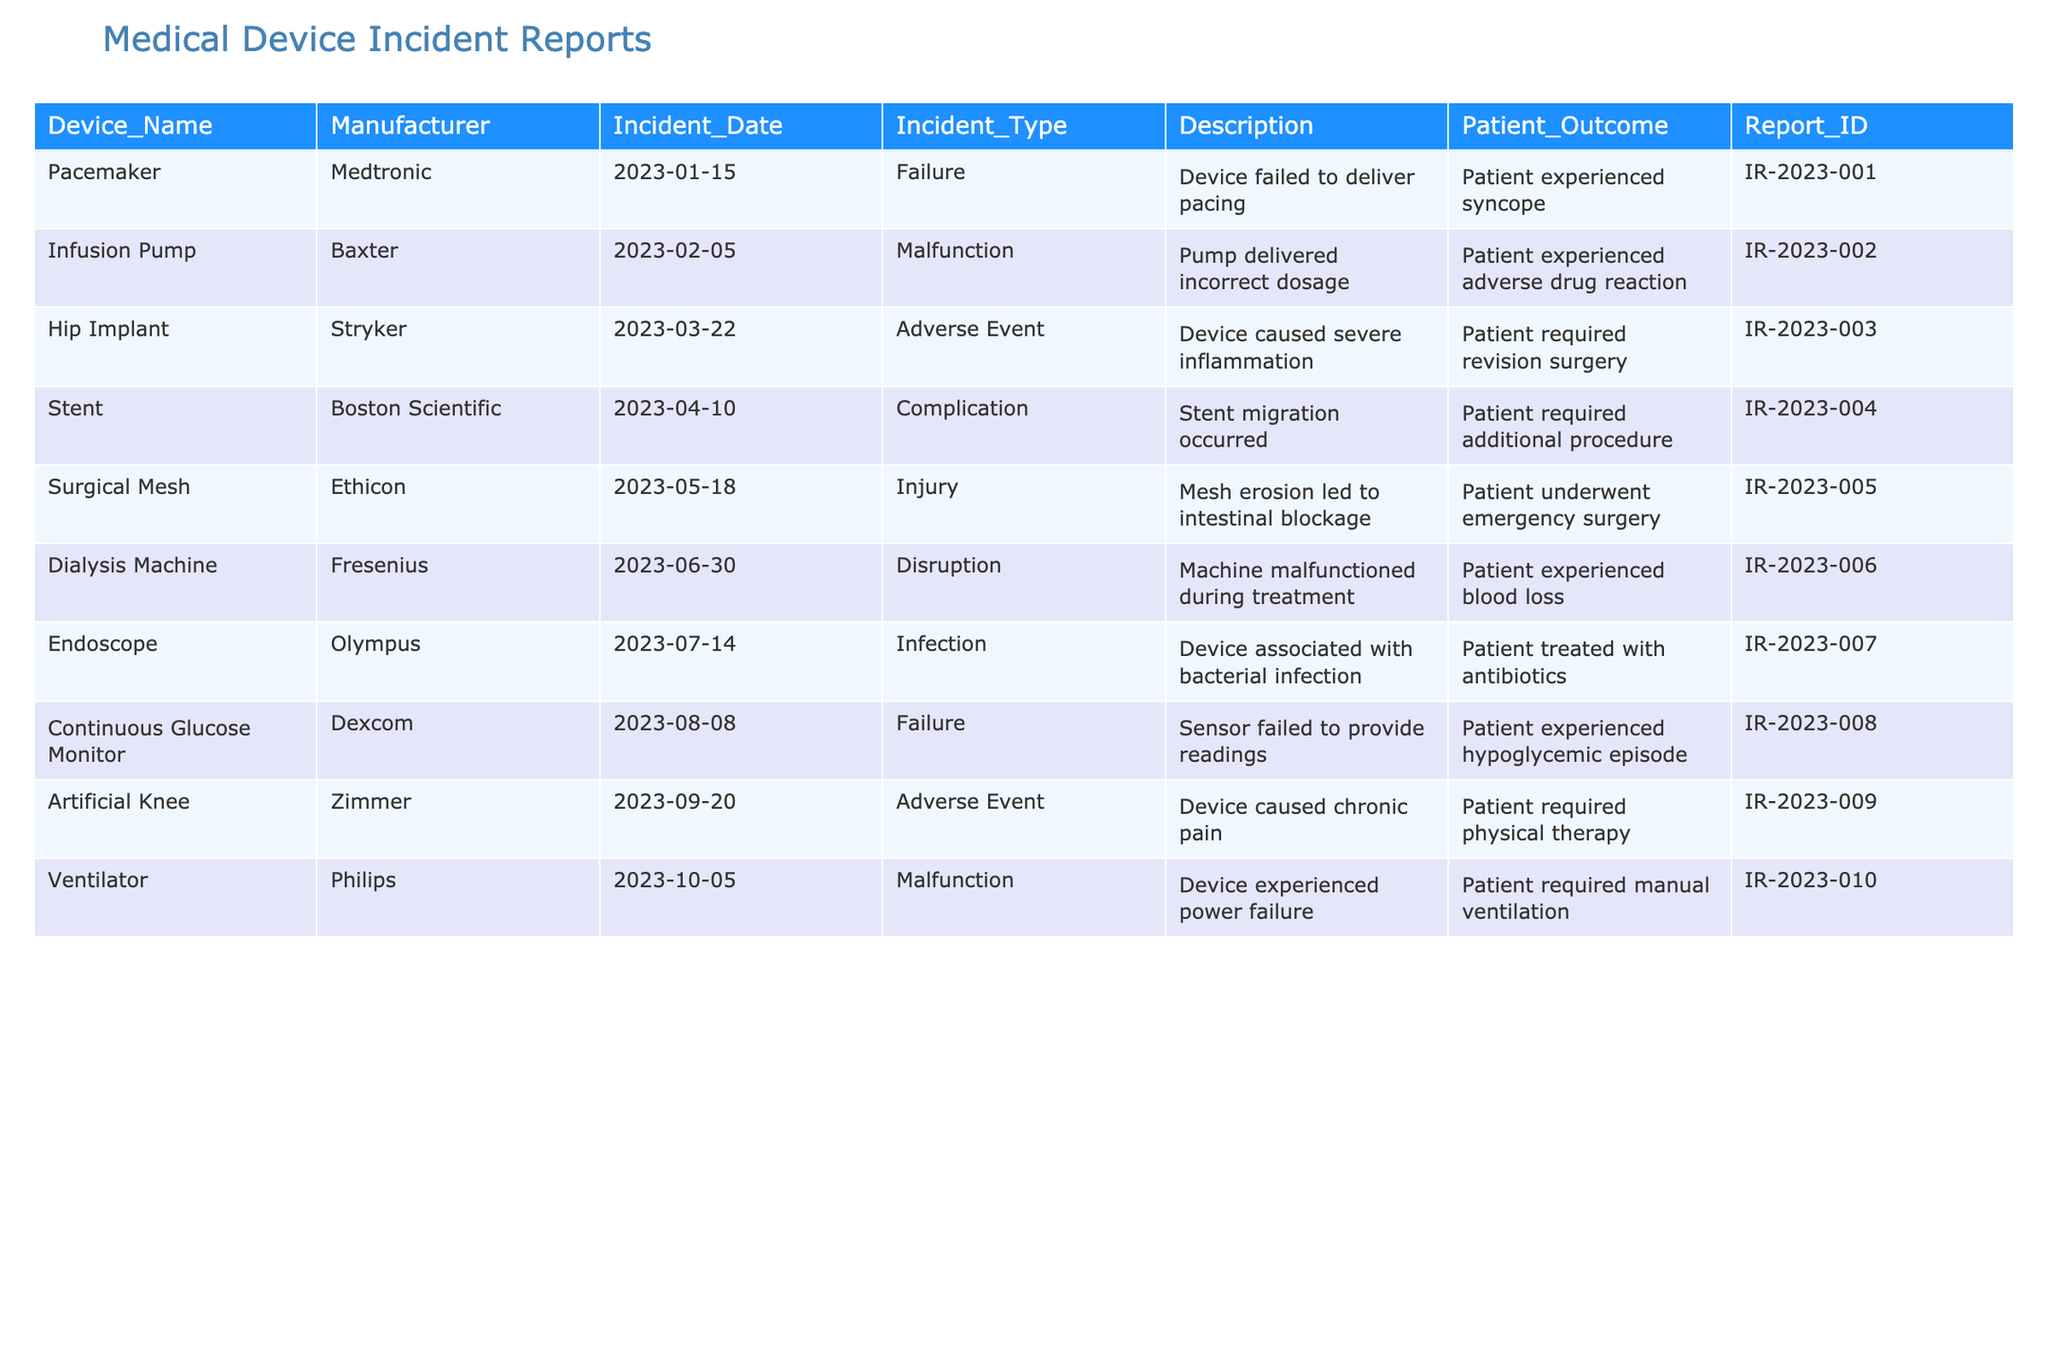What device had an incident involving a bacterial infection? Referring to the table under the "Incident Type" column, I find the "Infection" type associated with the "Endoscope" device by Olympus that occurred on "2023-07-14."
Answer: Endoscope How many total incidents were reported for devices by Medtronic? Looking at the "Manufacturer" column, I identify one incident associated with Medtronic, specifically the Pacemaker logged on "2023-01-15."
Answer: 1 Did any patients require surgery as a result of device incidents? By scanning the "Patient Outcome" column, I observe multiple entries indicating surgery requirements: one for the Hip Implant, one for the Surgical Mesh, and one for the Infusion Pump. Therefore, the answer is yes.
Answer: Yes What was the incident date for the Hip Implant? The table lists the Hip Implant incident date as "2023-03-22," which can be directly retrieved from the "Incident_Date" column.
Answer: 2023-03-22 Which device experienced a power failure? Checking the "Description" column shows that the Ventilator from Philips had a "power failure," logged on "2023-10-05."
Answer: Ventilator How many different manufacturers are listed in the table? The table features devices from six distinct manufacturers: Medtronic, Baxter, Stryker, Boston Scientific, Ethicon, Fresenius, Olympus, Dexcom, Zimmer, and Philips. This totals to nine different manufacturers.
Answer: 9 Which device's incident involved chronic pain for the patient? In the "Description" column, the incident linked to the Artificial Knee indicates that it caused "chronic pain," as recorded on "2023-09-20."
Answer: Artificial Knee What is the median date of incidents recorded in the table? To find the median date, I first arrange all incident dates chronologically. The list of dates is: 2023-01-15, 2023-02-05, 2023-03-22, 2023-04-10, 2023-05-18, 2023-06-30, 2023-07-14, 2023-08-08, 2023-09-20, 2023-10-05. With 10 entries, the median will be the average of the 5th and 6th dates: the 5th is "2023-05-18", and the 6th is "2023-06-30," which averages to "2023-06-03."
Answer: 2023-06-03 